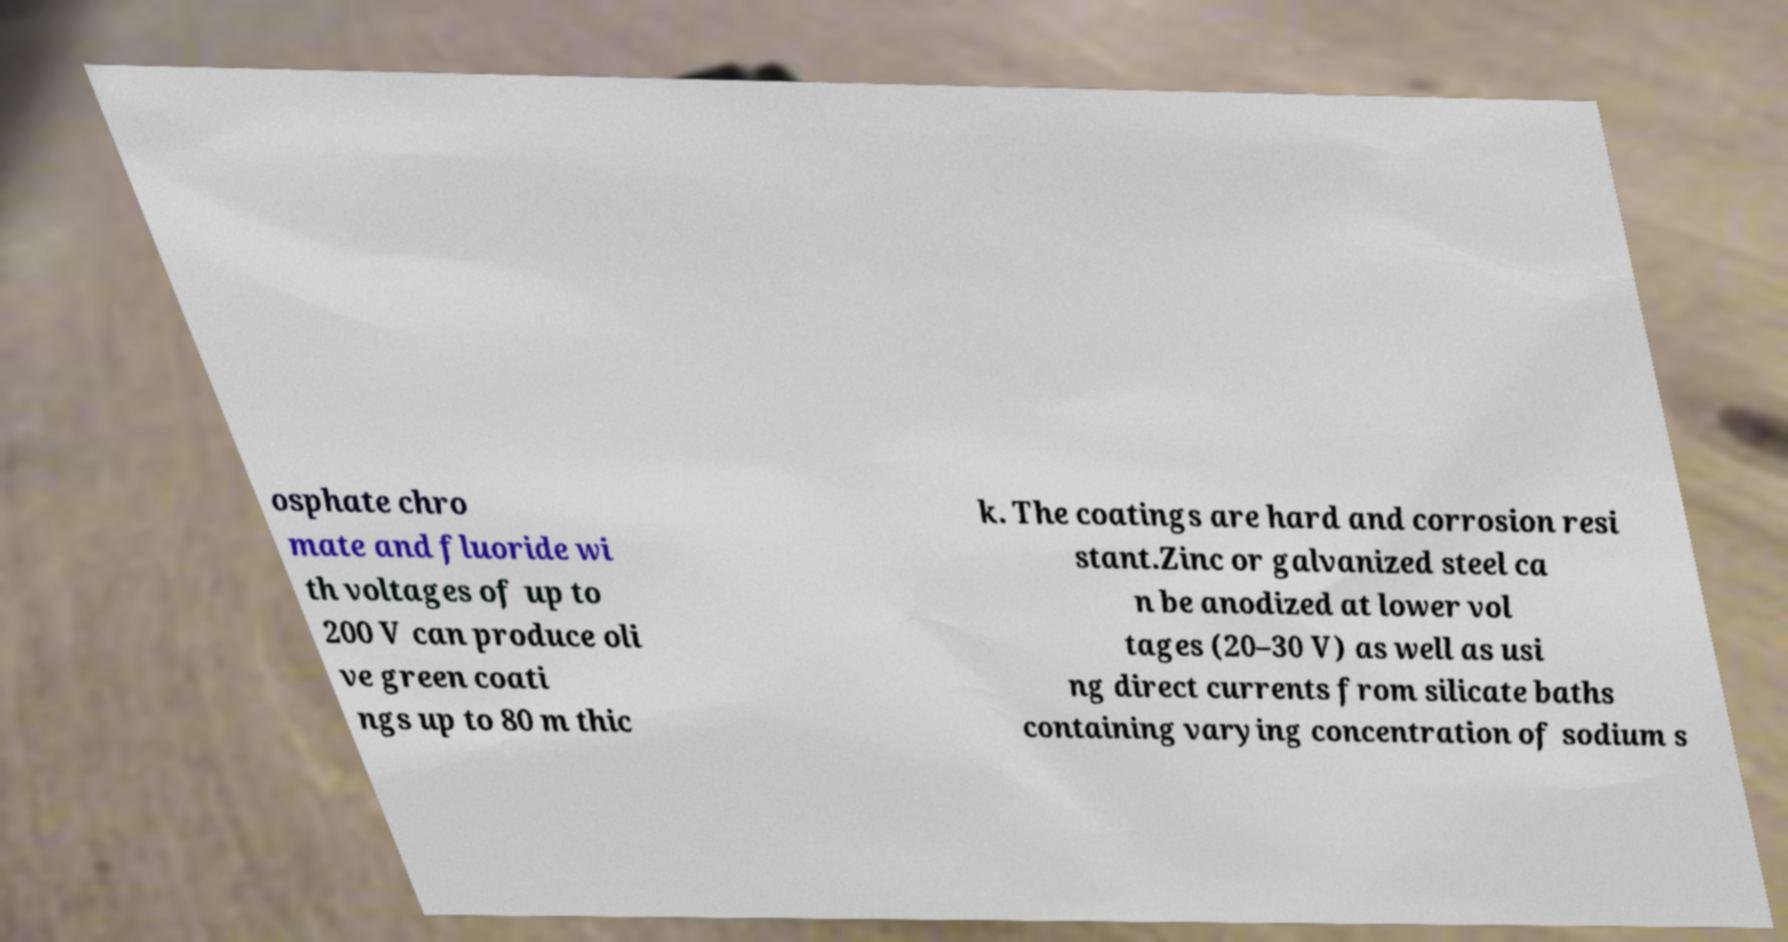What messages or text are displayed in this image? I need them in a readable, typed format. osphate chro mate and fluoride wi th voltages of up to 200 V can produce oli ve green coati ngs up to 80 m thic k. The coatings are hard and corrosion resi stant.Zinc or galvanized steel ca n be anodized at lower vol tages (20–30 V) as well as usi ng direct currents from silicate baths containing varying concentration of sodium s 